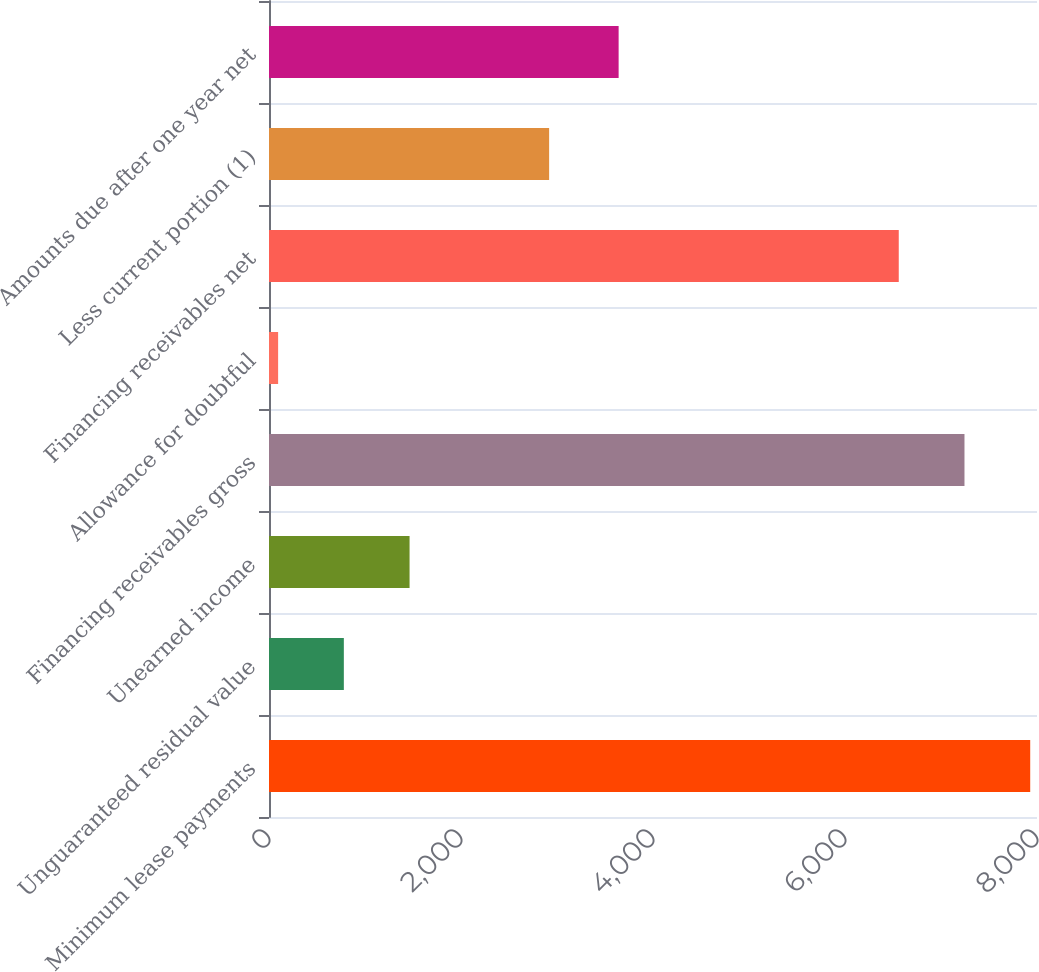Convert chart. <chart><loc_0><loc_0><loc_500><loc_500><bar_chart><fcel>Minimum lease payments<fcel>Unguaranteed residual value<fcel>Unearned income<fcel>Financing receivables gross<fcel>Allowance for doubtful<fcel>Financing receivables net<fcel>Less current portion (1)<fcel>Amounts due after one year net<nl><fcel>7929.2<fcel>779.6<fcel>1464.2<fcel>7244.6<fcel>95<fcel>6560<fcel>2918<fcel>3642<nl></chart> 